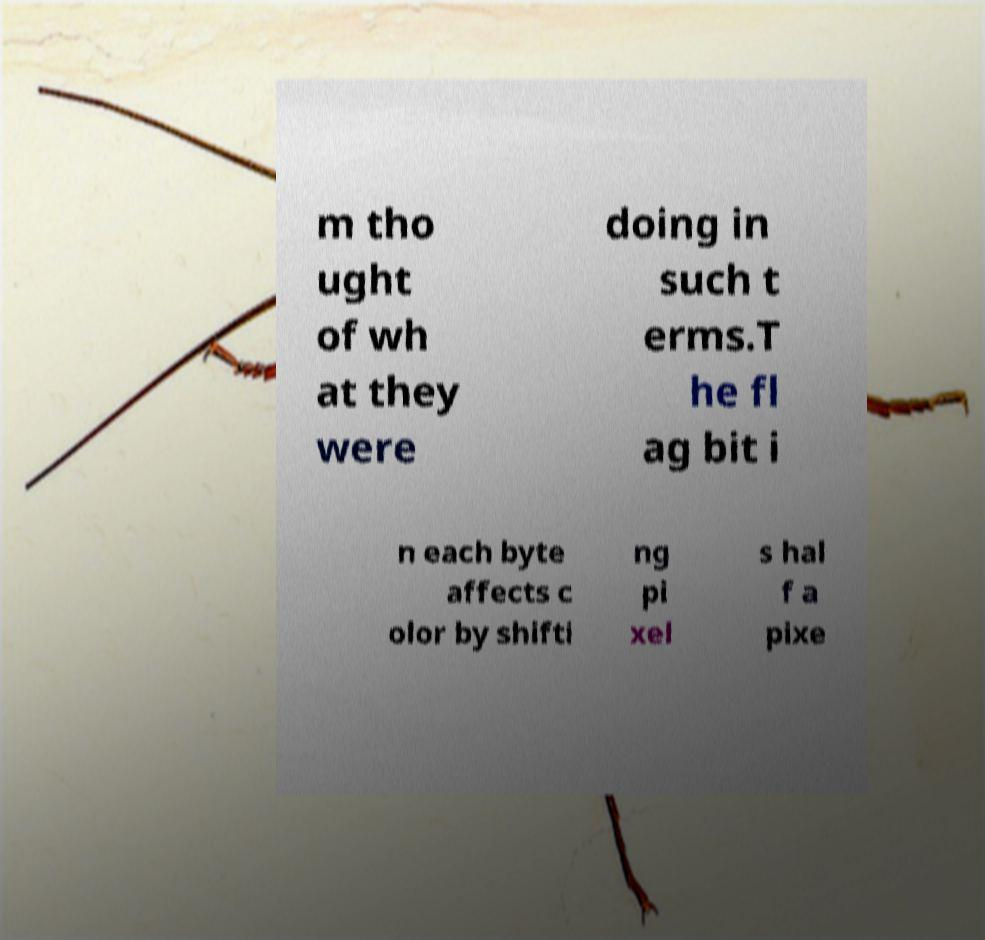For documentation purposes, I need the text within this image transcribed. Could you provide that? m tho ught of wh at they were doing in such t erms.T he fl ag bit i n each byte affects c olor by shifti ng pi xel s hal f a pixe 